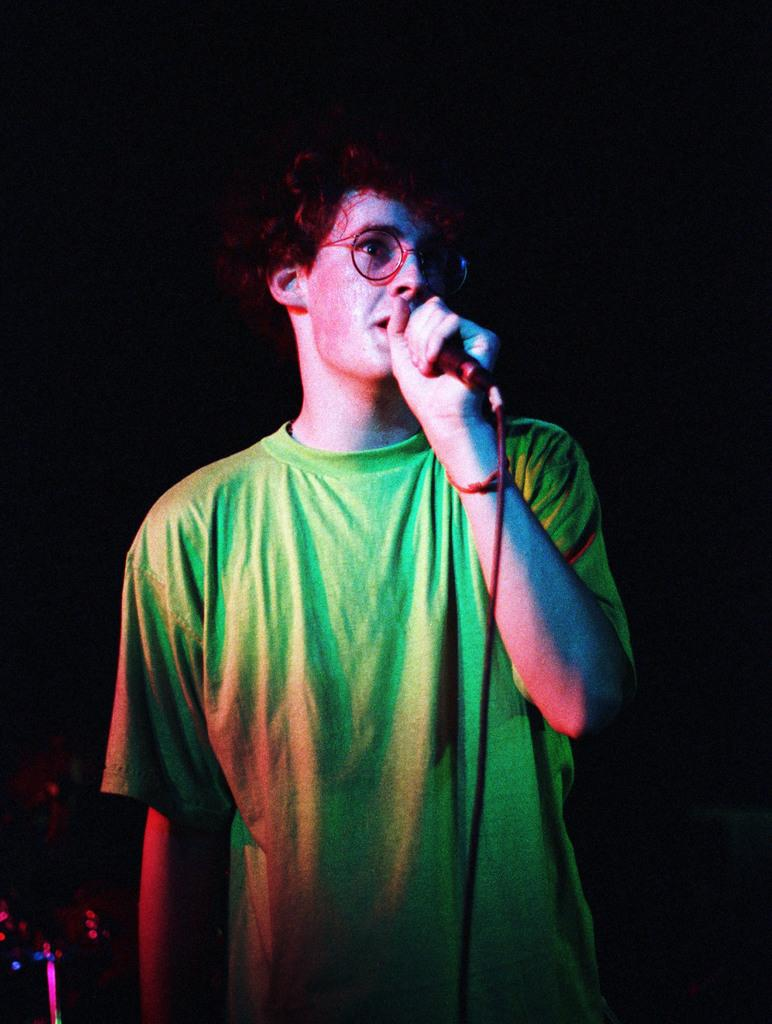What is the main subject of the image? There is a person in the image. What is the person holding in the image? The person is holding a microphone. Who is the person looking at in the image? The person is looking at someone. What type of jail can be seen in the background of the image? There is no jail present in the image; it only features a person holding a microphone and looking at someone. 